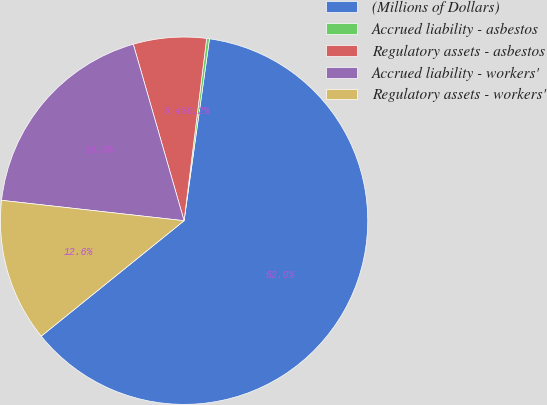Convert chart to OTSL. <chart><loc_0><loc_0><loc_500><loc_500><pie_chart><fcel>(Millions of Dollars)<fcel>Accrued liability - asbestos<fcel>Regulatory assets - asbestos<fcel>Accrued liability - workers'<fcel>Regulatory assets - workers'<nl><fcel>61.98%<fcel>0.25%<fcel>6.42%<fcel>18.77%<fcel>12.59%<nl></chart> 